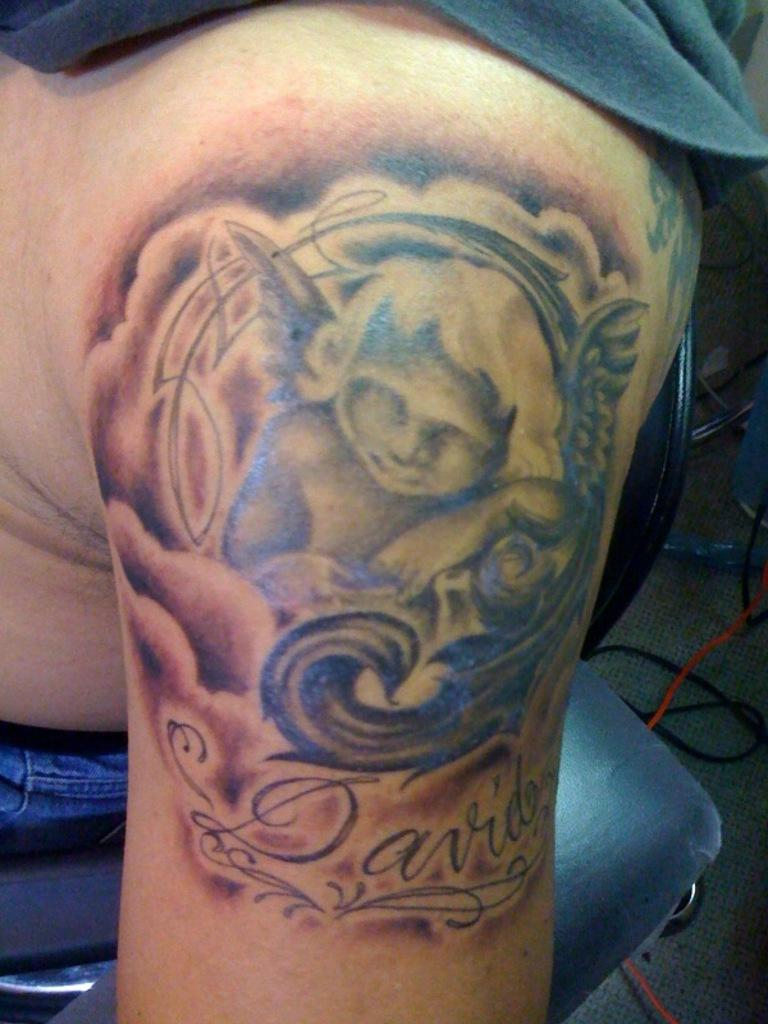What is depicted in the image? There is a tattoo in the image. What is the subject of the tattoo? The tattoo is of a baby. On which part of the body is the tattoo located? The tattoo is on human skin. What type of string is being used to hold the light bulb in the image? There is no string or light bulb present in the image; it only features a tattoo of a baby on human skin. 